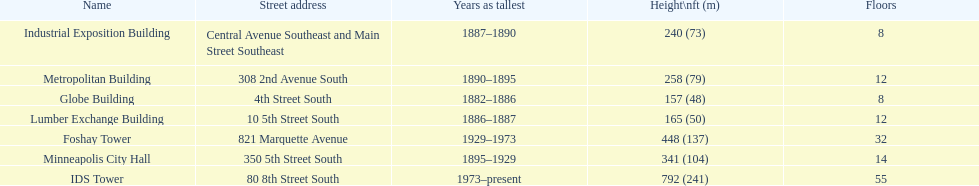How long did the lumber exchange building stand as the tallest building? 1 year. 